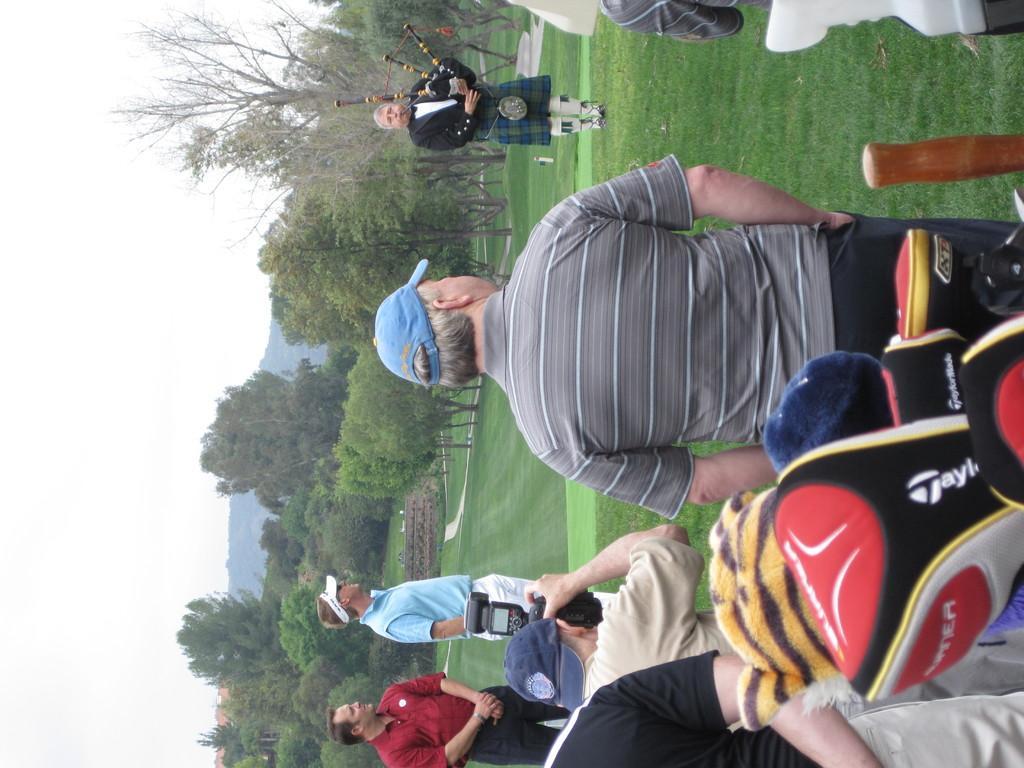Could you give a brief overview of what you see in this image? In the image there is a person performing some activity and in front of him, the crowd is watching and all of them are standing on the land covered with grass, in the background there are many trees and behind the trees there is a mountain. 